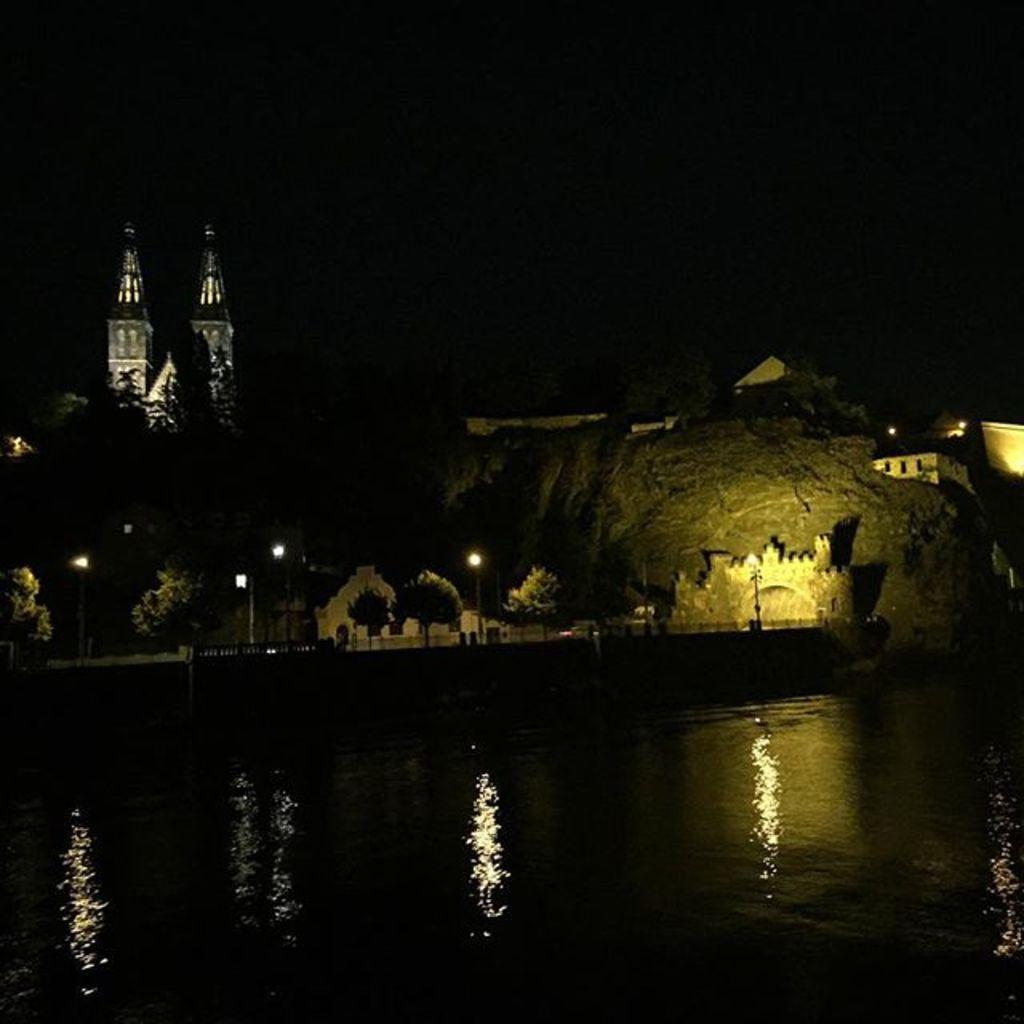In one or two sentences, can you explain what this image depicts? In this image we can see there is water at the bottom. In the middle there is a bridge. In the background it looks like a tower. There are few lamp poles on the bridge. On the right side it looks a rock. Beside the rock there are buildings. 